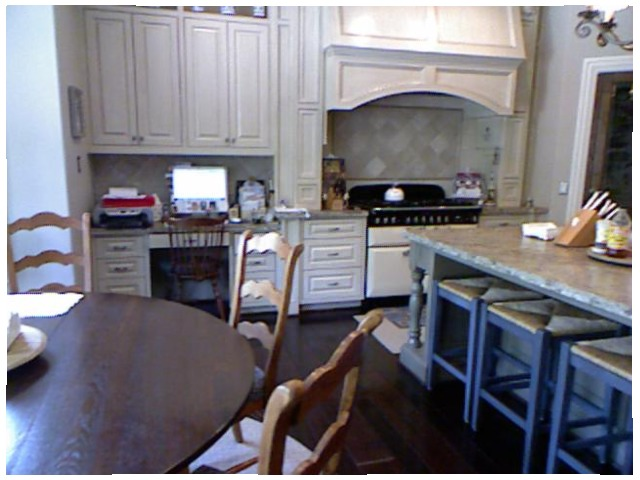<image>
Is the chair on the table? No. The chair is not positioned on the table. They may be near each other, but the chair is not supported by or resting on top of the table. Is there a chair behind the table? No. The chair is not behind the table. From this viewpoint, the chair appears to be positioned elsewhere in the scene. Is there a stool behind the table? No. The stool is not behind the table. From this viewpoint, the stool appears to be positioned elsewhere in the scene. Is there a chair next to the table? Yes. The chair is positioned adjacent to the table, located nearby in the same general area. 